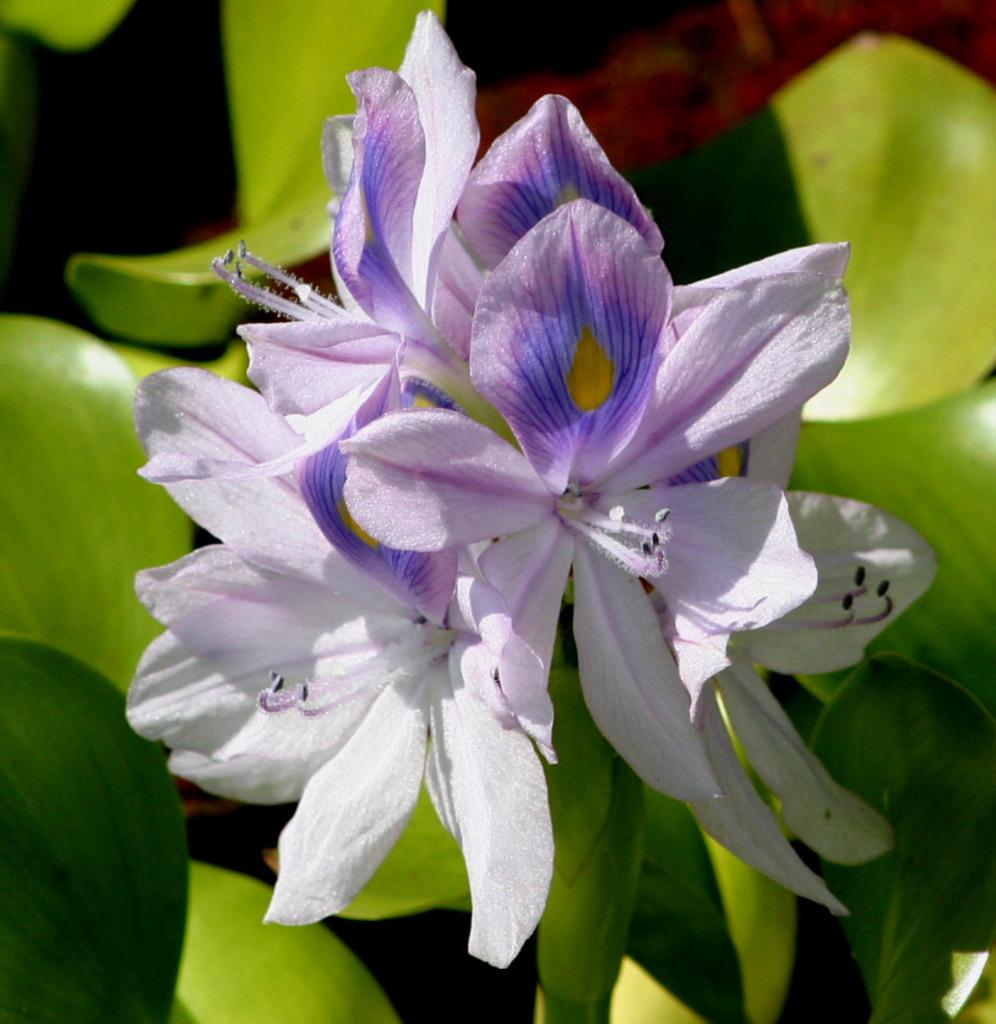What type of plants can be seen in the image? There are flowers in the image. What colors are the flowers? The flowers are white and purple in color. What other part of the plant is visible in the image? There are green leaves in the image. What type of chain can be seen connecting the flowers in the image? There is no chain present in the image; the flowers are not connected by any visible chain. 